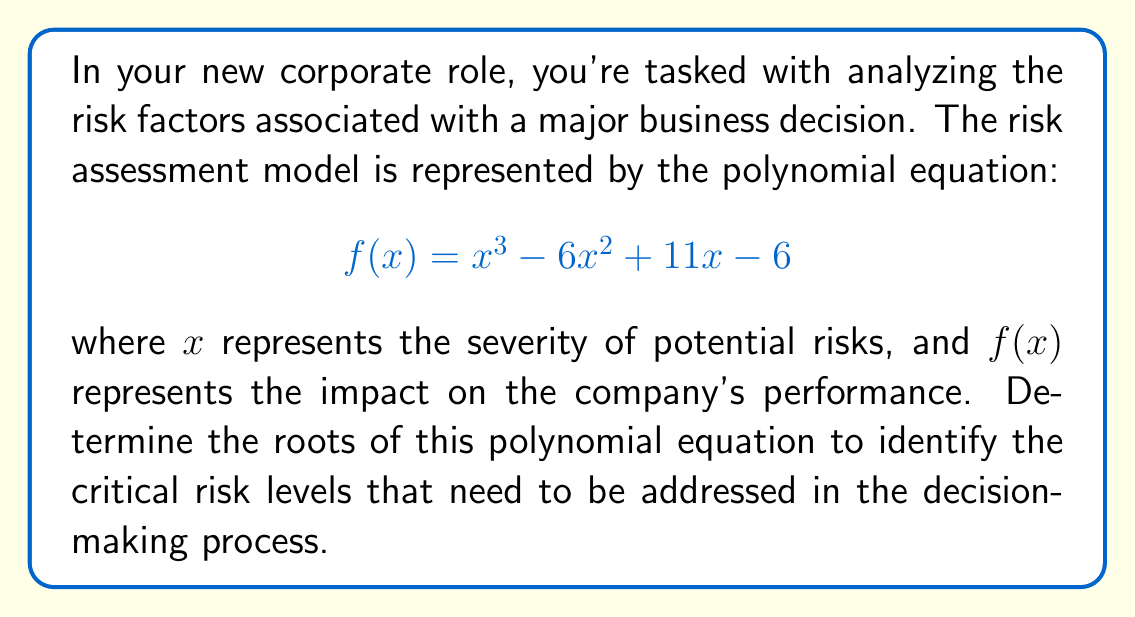Teach me how to tackle this problem. To find the roots of the polynomial equation, we'll use the factor theorem and synthetic division:

1) First, let's check if 1 is a root by evaluating $f(1)$:
   $f(1) = 1^3 - 6(1)^2 + 11(1) - 6 = 1 - 6 + 11 - 6 = 0$
   So, 1 is indeed a root.

2) Use synthetic division to divide $f(x)$ by $(x-1)$:

   $$
   \begin{array}{r|rrrr}
   1 & 1 & -6 & 11 & -6 \\
     & 1 & -5 & 6 &    \\
   \hline
     & 1 & -5 & 6 & 0  \\
   \end{array}
   $$

3) The result of the division is $x^2 - 5x + 6$, so:
   $f(x) = (x-1)(x^2 - 5x + 6)$

4) Now, we need to factor $x^2 - 5x + 6$:
   This is a quadratic equation in the form $ax^2 + bx + c$, where $a=1$, $b=-5$, and $c=6$.
   We can factor it as: $(x-2)(x-3)$

5) Therefore, the fully factored form of $f(x)$ is:
   $f(x) = (x-1)(x-2)(x-3)$

6) The roots of the polynomial are the values that make each factor equal to zero:
   $x-1=0$, $x-2=0$, and $x-3=0$
   So, the roots are $x=1$, $x=2$, and $x=3$
Answer: The roots are 1, 2, and 3. 